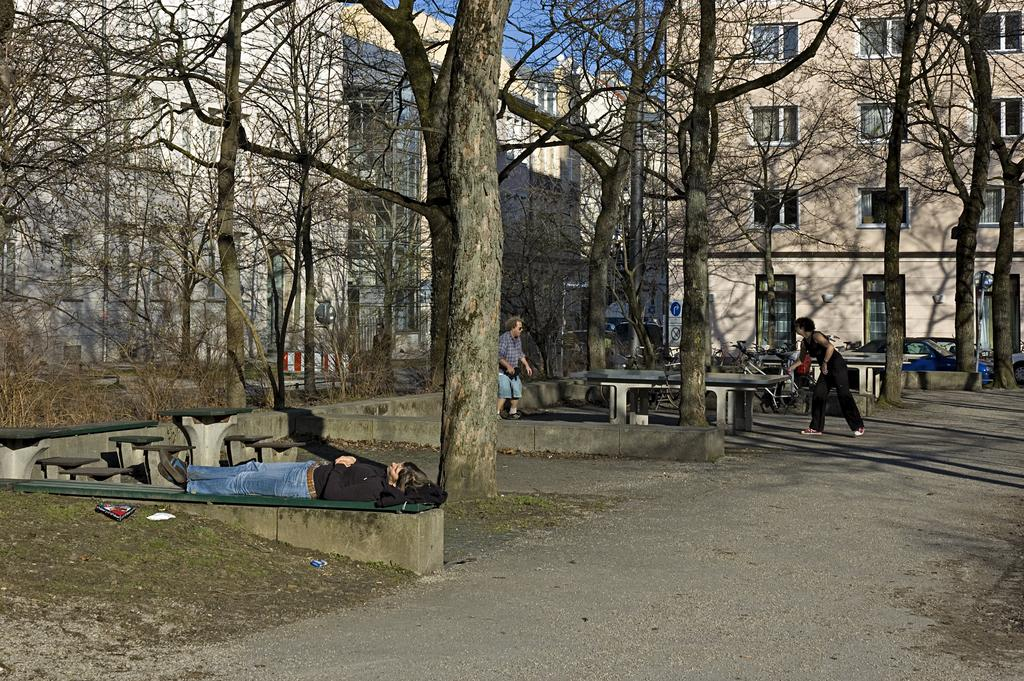What is the main subject of the image? There is a person sleeping on a bench in the image. What are the other persons in the image doing? Two other persons are playing a game in the background. What type of vegetation can be seen in the background? Dried trees are visible in the background. What is the color scheme of the buildings in the background? The buildings in the background have cream and white colors. What is the color of the sky in the image? The sky is blue in the image. Can you tell me how many ants are crawling on the person sleeping on the bench? There are no ants visible on the person sleeping on the bench in the image. What type of zipper can be seen on the tree in the background? There is no tree or zipper present in the image. 